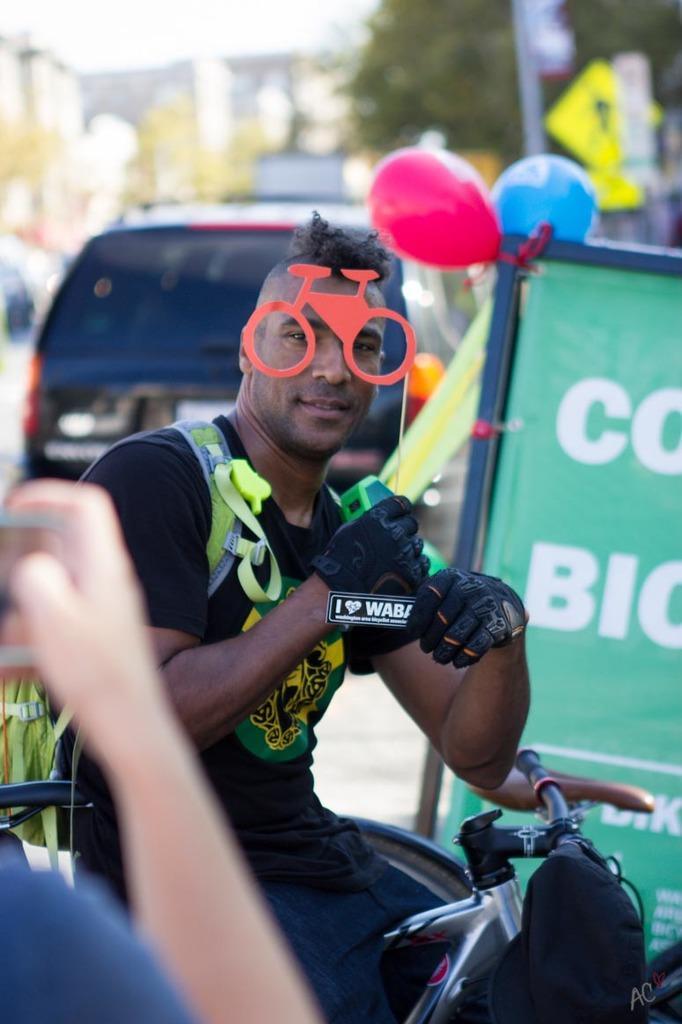Describe this image in one or two sentences. In this picture there is a boy who is sitting on a bicycle at the center of the image and there is a bicycle tattoo on his face and the boy is holding a tag in his left hand and there is a car behind the boy. 